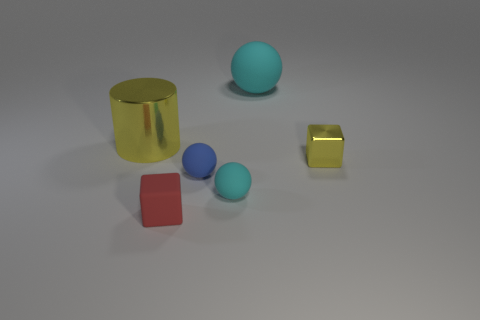What is the shape of the tiny rubber thing that is the same color as the large rubber thing?
Give a very brief answer. Sphere. What material is the tiny blue thing?
Your answer should be very brief. Rubber. Is the number of red cubes right of the tiny cyan object greater than the number of small red cubes?
Offer a very short reply. No. Is there a tiny yellow metallic object?
Provide a short and direct response. Yes. How many other objects are there of the same shape as the red thing?
Keep it short and to the point. 1. There is a cube to the right of the tiny red matte cube; does it have the same color as the metal thing that is behind the shiny block?
Give a very brief answer. Yes. What is the size of the shiny thing that is to the right of the tiny ball that is behind the cyan sphere in front of the yellow shiny cylinder?
Ensure brevity in your answer.  Small. There is a thing that is both behind the small blue matte sphere and in front of the big yellow metal thing; what is its shape?
Offer a very short reply. Cube. Are there an equal number of large things right of the red rubber cube and cyan rubber spheres that are left of the yellow cylinder?
Offer a very short reply. No. Is there a brown ball made of the same material as the blue sphere?
Keep it short and to the point. No. 